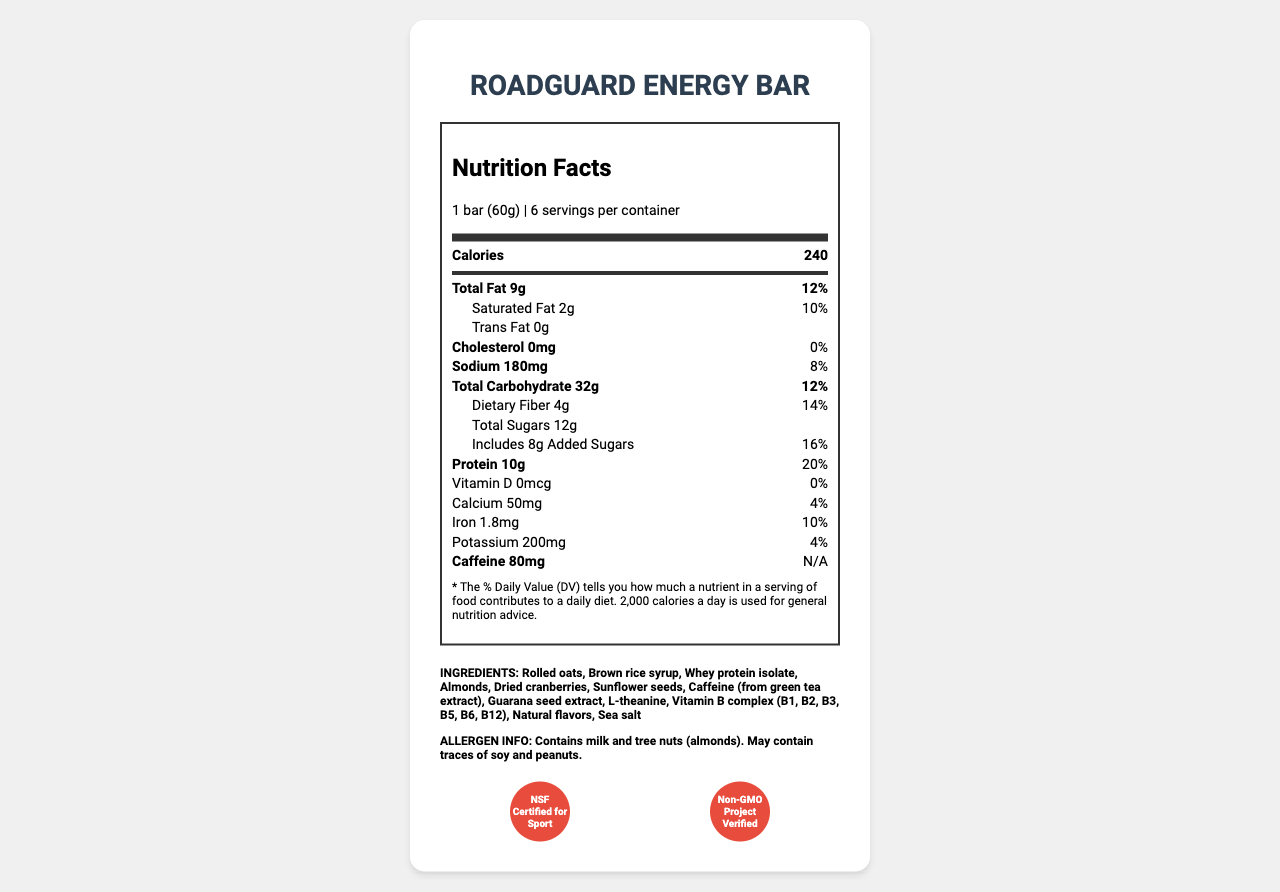what is the serving size of the RoadGuard Energy Bar? The serving size is clearly stated at the top of the document as "1 bar (60g)".
Answer: 1 bar (60g) how many calories are there per serving? The document lists "Calories" with the value of "240" under the main information section.
Answer: 240 what is the total fat content per serving and its daily value percentage? The total fat content is shown as "9g" with a daily value percentage of "12%".
Answer: 9g, 12% what ingredients are listed for the RoadGuard Energy Bar? The ingredients are listed in the section labeled "INGREDIENTS".
Answer: Rolled oats, Brown rice syrup, Whey protein isolate, Almonds, Dried cranberries, Sunflower seeds, Caffeine (from green tea extract), Guarana seed extract, L-theanine, Vitamin B complex (B1, B2, B3, B5, B6, B12), Natural flavors, Sea salt how much caffeine does the RoadGuard Energy Bar contain? The document specifies "Caffeine" with an amount of "80mg" listed under the nutrient information section.
Answer: 80mg how much added sugar is in each serving? The document lists "Includes 8g Added Sugars" under the sub-nutrient section.
Answer: 8g which vitamin is not present in the RoadGuard Energy Bar? A. Vitamin D B. Vitamin B12 C. Vitamin C D. Vitamin E The nutrient information shows "Vitamin D 0mcg" with a daily value of "0%", indicating it is not present.
Answer: A. Vitamin D what is the main ingredient mentioned for sustainable energy release in the claims and features? A. Protein B. Fiber C. Caffeine D. Vitamins The claims and features section highlights "80mg of caffeine per bar" which provides sustained energy release.
Answer: C. Caffeine is the RoadGuard Energy Bar GMO? The certification section includes "Non-GMO Project Verified," indicating it is not genetically modified.
Answer: No does the RoadGuard Energy Bar contain any artificial preservatives or colors? The claims and features section states "No artificial preservatives or colors".
Answer: No summarize the main idea of the document. The document details all nutritional facts, ingredients, certifications, claims, and features of the RoadGuard Energy Bar, emphasizing its suitability for sustained energy and on-the-go consumption.
Answer: The RoadGuard Energy Bar is designed for sustained energy release, particularly suitable for long shifts. It contains a balanced mix of macronutrients, high in protein and fiber, and includes 80mg of caffeine per serving. The bar is free from artificial preservatives and colors and is certified as both NSF Certified for Sport and Non-GMO Project Verified. It also contains specific allergen information and storage instructions. what is the manufacturer's name and address? The manufacturer information section provides the manufacturer's name as "PatrolNutrition Inc." and the address as "1234 Highway Drive, Safety City, ST 12345".
Answer: PatrolNutrition Inc., 1234 Highway Drive, Safety City, ST 12345 what is the recommended storage condition for the RoadGuard Energy Bar? The storage instructions clearly state to store the product in a cool, dry place and to consume it within 14 days of opening.
Answer: Store in a cool, dry place. Consume within 14 days of opening. what is the exact percentage of daily value for dietary fiber? The nutrient row under dietary fiber states "4g" with a daily value percentage of "14%".
Answer: 14% can the RoadGuard Energy Bar be considered safe for people with nut allergies? The allergen information states that it contains milk and tree nuts (almonds) and may contain traces of soy and peanuts.
Answer: No what specific complex of vitamins does the RoadGuard Energy Bar contain? The ingredients section lists "Vitamin B complex (B1, B2, B3, B5, B6, B12)" among the ingredients.
Answer: Vitamin B complex (B1, B2, B3, B5, B6, B12) is there information about the bar's gluten content? The document doesn't provide specific information about gluten content.
Answer: Not enough information 